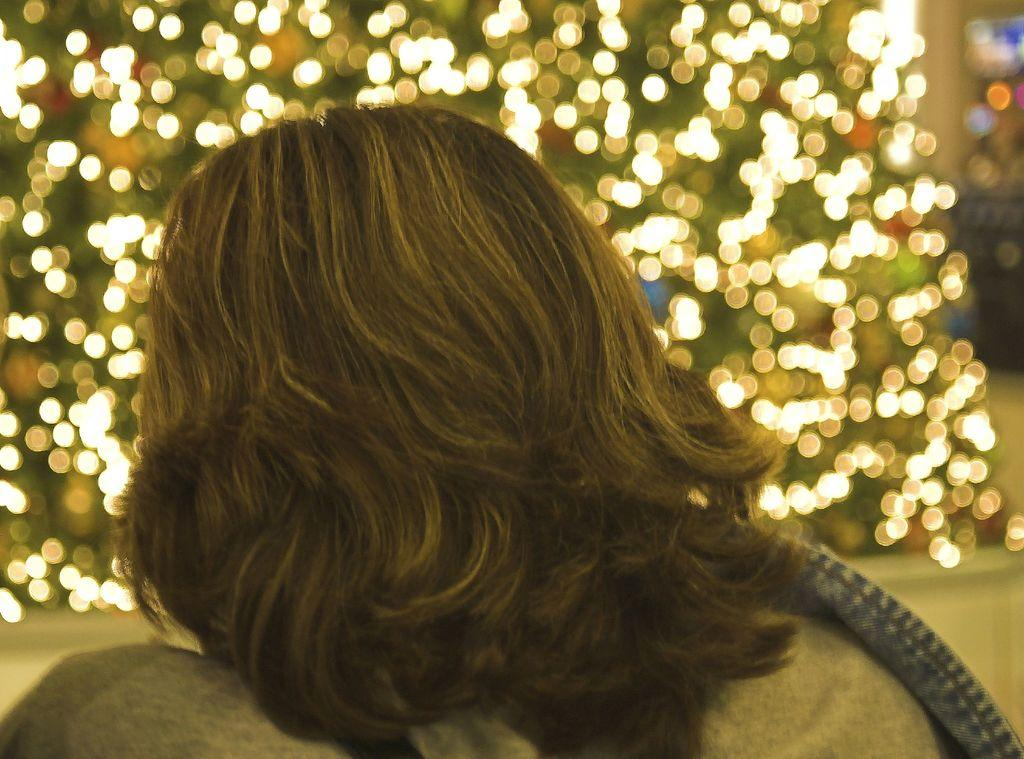What part of a person can be seen in the image? There is a person's hair visible in the image. What can be seen in the background of the image? There are lights in the background of the image. Where is the family located in the image? There is no family present in the image; only a person's hair and lights in the background can be seen. What type of furniture can be seen in the bedroom in the image? There is no bedroom or furniture present in the image. 